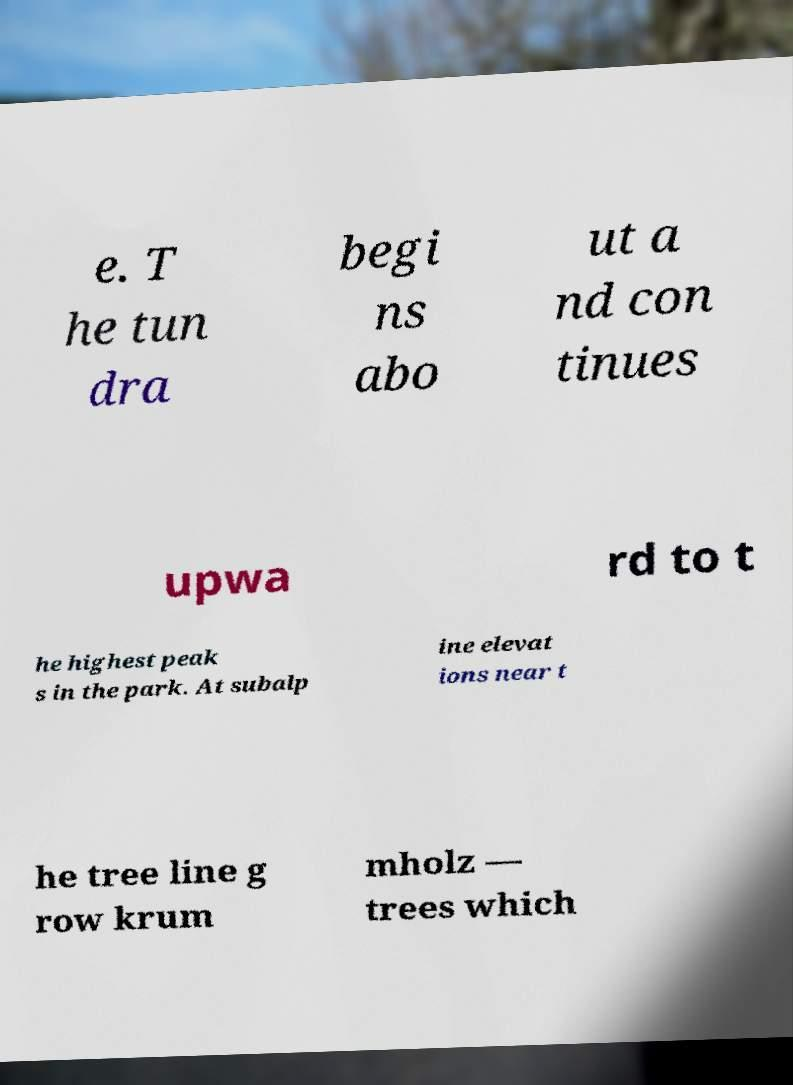Can you read and provide the text displayed in the image?This photo seems to have some interesting text. Can you extract and type it out for me? e. T he tun dra begi ns abo ut a nd con tinues upwa rd to t he highest peak s in the park. At subalp ine elevat ions near t he tree line g row krum mholz — trees which 